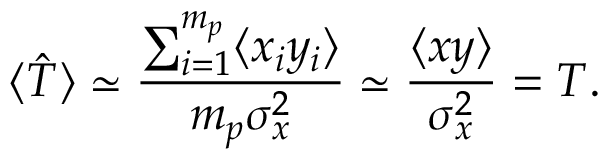<formula> <loc_0><loc_0><loc_500><loc_500>\langle \hat { T } \rangle \simeq \frac { \sum _ { i = 1 } ^ { m _ { p } } \langle x _ { i } y _ { i } \rangle } { m _ { p } \sigma _ { x } ^ { 2 } } \simeq \frac { \langle x y \rangle } { \sigma _ { x } ^ { 2 } } = T .</formula> 